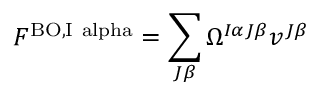<formula> <loc_0><loc_0><loc_500><loc_500>F ^ { { B O , } I \ a l p h a } = \sum _ { J \beta } \Omega ^ { I \alpha J \beta } v ^ { J \beta }</formula> 